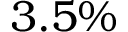Convert formula to latex. <formula><loc_0><loc_0><loc_500><loc_500>3 . 5 \%</formula> 